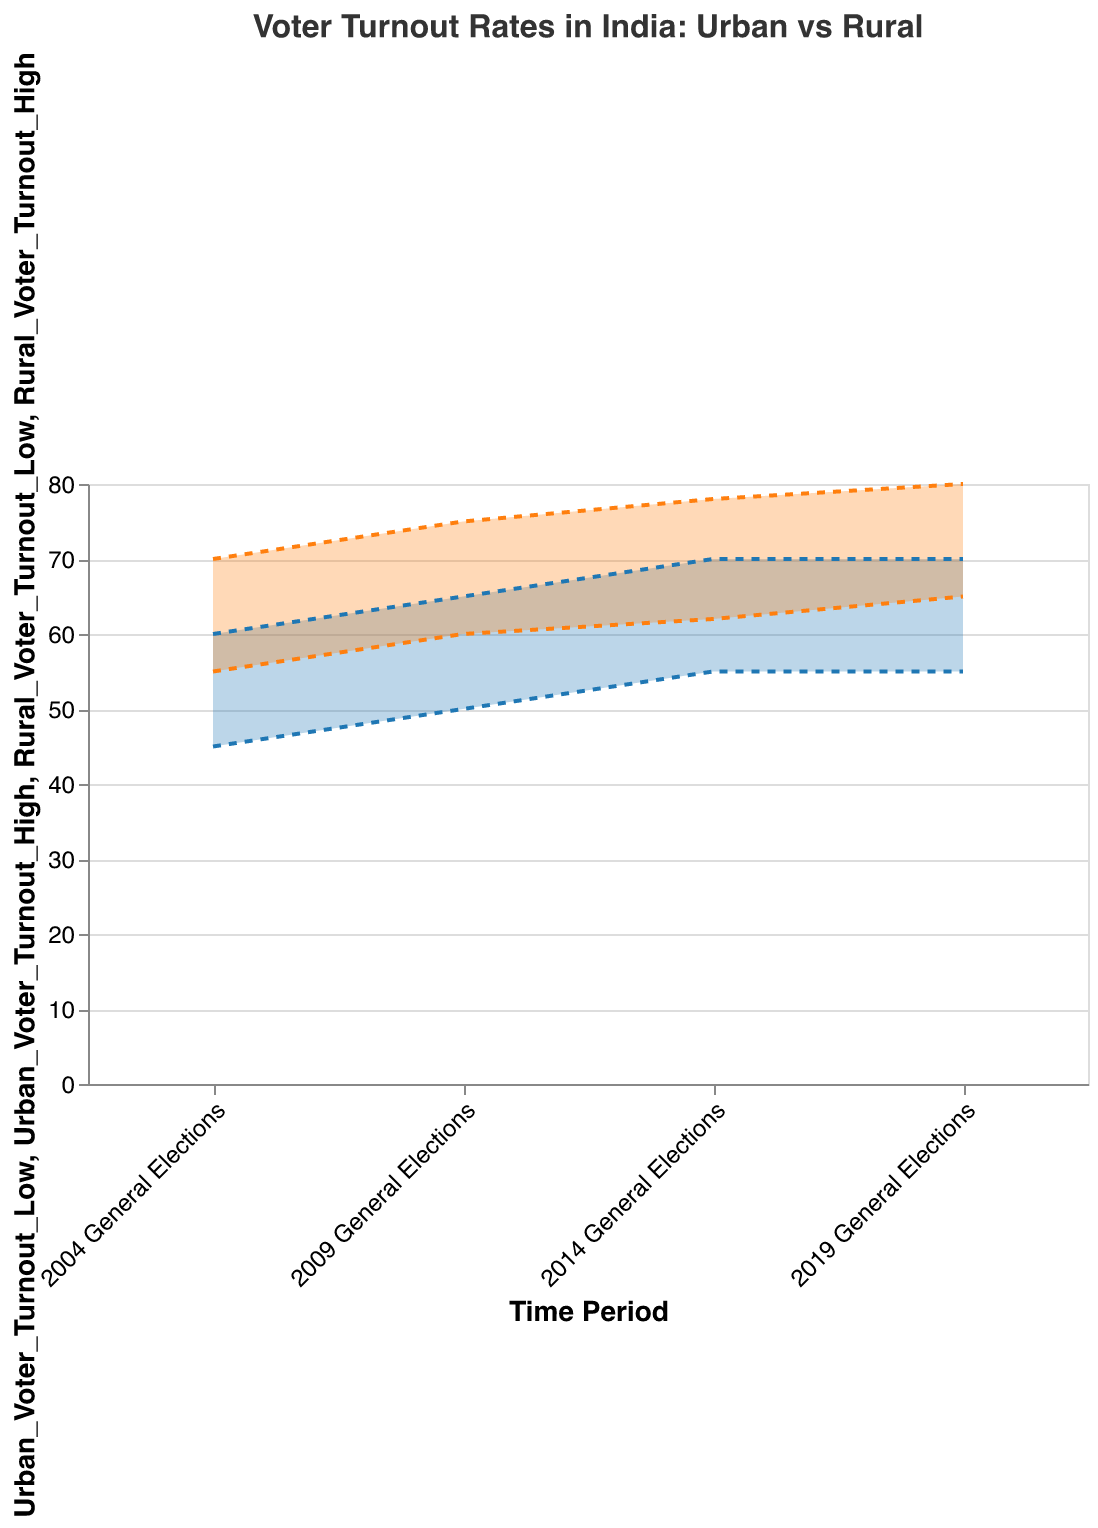What is the title of the chart? The title of the chart is visible at the top and reads, "Voter Turnout Rates in India: Urban vs Rural"
Answer: Voter Turnout Rates in India: Urban vs Rural During which election did rural areas have the highest voter turnout range? By looking at the range areas for rural voter turnout, the widest range (in orange) appears in the "2019 General Elections" where it spans from 65 to 80
Answer: 2019 General Elections How does the urban voter turnout range in the 2014 General Elections compare to that in the 2004 General Elections? The range in the 2014 General Elections is from 55 to 70, and in the 2004 General Elections, it is from 45 to 60. This shows an increase in both the lower and upper bounds over time
Answer: 55-70 (2014) vs 45-60 (2004) What is the approximate difference in the highest voter turnout between urban and rural areas in the 2009 General Elections? The highest voter turnout for urban areas in 2009 is 65, while for rural areas it is 75. The difference is 75 - 65
Answer: 10 What election year shows the smallest gap between the lowest voter turnout in urban and rural areas? Comparing the gaps, in the 2004 General Elections, the gap is 10 (55 - 45), in 2009 it is 10 (60 - 50), in 2014 it is 7 (62 - 55), and in 2019 it is 10 (65 - 55). Thus, the smallest gap is in 2014
Answer: 2014 General Elections Which trend is more stable across the elections, urban or rural voter turnout rates? The urban voter turnout rates (in blue) appear more stable as they span between 45 to 70 with slight increments, whereas the rural voter turnout rates (in orange) show a wider range of increase from 55-70 to 65-80
Answer: Urban voter turnout rates On average, how much did the highest rural voter turnout increase from 2004 to 2019? The highest rural voter turnout in 2004 was 70. In 2019, it was 80. The increase is 80 - 70. To find the average increase over the 4 elections (2004, 2009, 2014, 2019), perform: (80-70)/3 as there are 3 intervals
Answer: 3.33 per election What is the range area for urban voter turnout in the 2009 General Elections? The urban voter turnout in 2009 ranges from 50 to 65, which can be seen from the blue area spanning between these two points
Answer: 50 to 65 Does the urban voter turnout range ever surpass the rural voter turnout range? For all the given General Elections, rural voter turnout ranges are consistently higher than the urban voter turnout ranges
Answer: No 